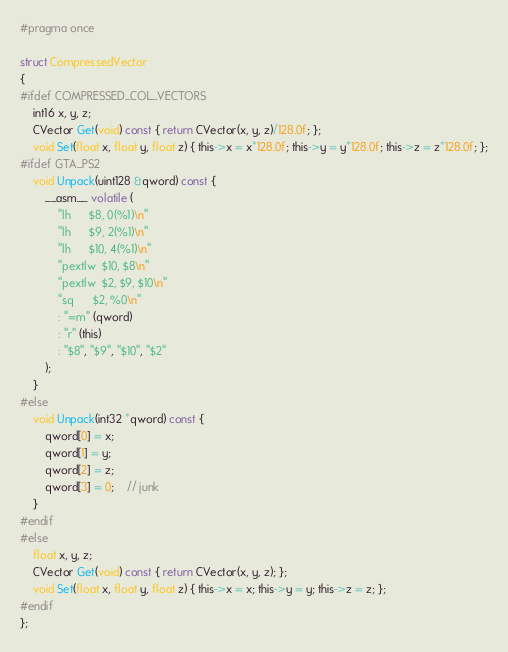Convert code to text. <code><loc_0><loc_0><loc_500><loc_500><_C_>#pragma once

struct CompressedVector
{
#ifdef COMPRESSED_COL_VECTORS
	int16 x, y, z;
	CVector Get(void) const { return CVector(x, y, z)/128.0f; };
	void Set(float x, float y, float z) { this->x = x*128.0f; this->y = y*128.0f; this->z = z*128.0f; };
#ifdef GTA_PS2
	void Unpack(uint128 &qword) const {
		__asm__ volatile (
			"lh      $8, 0(%1)\n"
			"lh      $9, 2(%1)\n"
			"lh      $10, 4(%1)\n"
			"pextlw  $10, $8\n"
			"pextlw  $2, $9, $10\n"
			"sq      $2, %0\n"
			: "=m" (qword)
			: "r" (this)
			: "$8", "$9", "$10", "$2"
		);
	}
#else
	void Unpack(int32 *qword) const {
		qword[0] = x;
		qword[1] = y;
		qword[2] = z;
		qword[3] = 0;	// junk
	}
#endif
#else
	float x, y, z;
	CVector Get(void) const { return CVector(x, y, z); };
	void Set(float x, float y, float z) { this->x = x; this->y = y; this->z = z; };
#endif
};</code> 